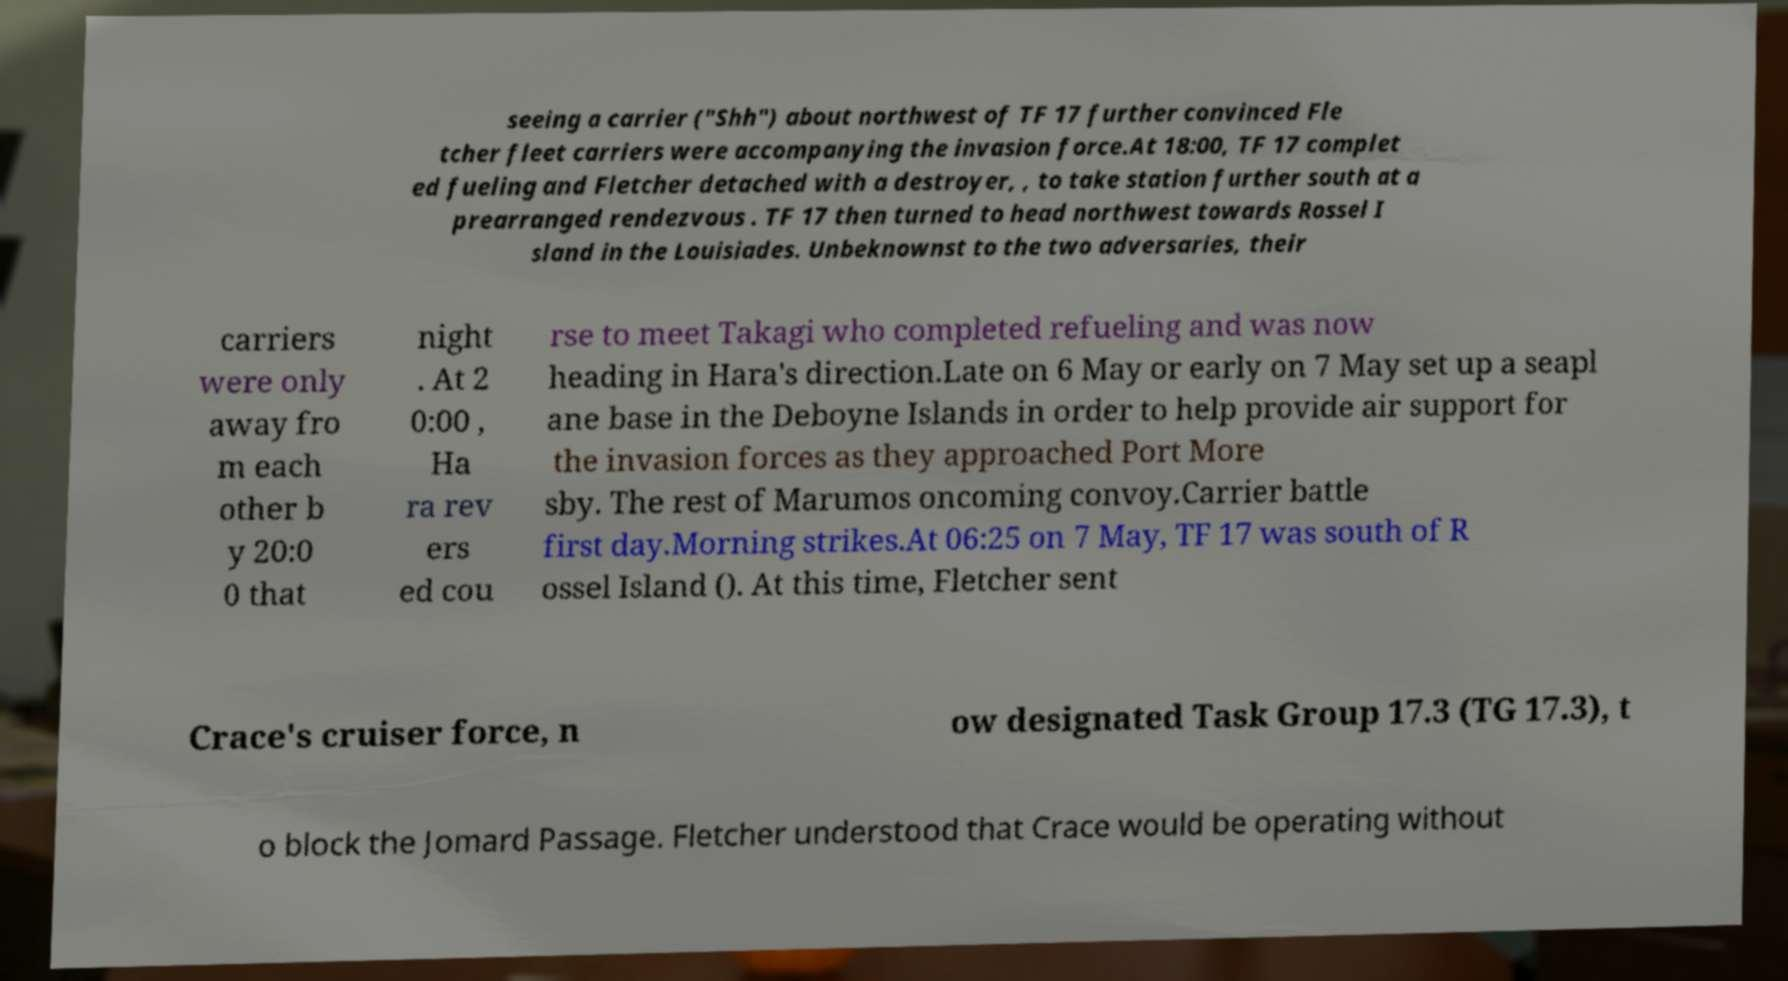Please identify and transcribe the text found in this image. seeing a carrier ("Shh") about northwest of TF 17 further convinced Fle tcher fleet carriers were accompanying the invasion force.At 18:00, TF 17 complet ed fueling and Fletcher detached with a destroyer, , to take station further south at a prearranged rendezvous . TF 17 then turned to head northwest towards Rossel I sland in the Louisiades. Unbeknownst to the two adversaries, their carriers were only away fro m each other b y 20:0 0 that night . At 2 0:00 , Ha ra rev ers ed cou rse to meet Takagi who completed refueling and was now heading in Hara's direction.Late on 6 May or early on 7 May set up a seapl ane base in the Deboyne Islands in order to help provide air support for the invasion forces as they approached Port More sby. The rest of Marumos oncoming convoy.Carrier battle first day.Morning strikes.At 06:25 on 7 May, TF 17 was south of R ossel Island (). At this time, Fletcher sent Crace's cruiser force, n ow designated Task Group 17.3 (TG 17.3), t o block the Jomard Passage. Fletcher understood that Crace would be operating without 